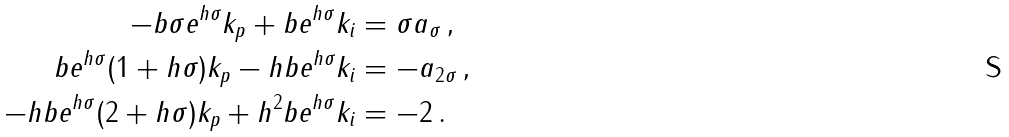Convert formula to latex. <formula><loc_0><loc_0><loc_500><loc_500>- b \sigma e ^ { h \sigma } k _ { p } + b e ^ { h \sigma } k _ { i } & = \sigma a _ { \sigma } \, , \\ b e ^ { h \sigma } ( 1 + h \sigma ) k _ { p } - h b e ^ { h \sigma } k _ { i } & = - a _ { 2 \sigma } \, , \\ - h b e ^ { h \sigma } ( 2 + h \sigma ) k _ { p } + h ^ { 2 } b e ^ { h \sigma } k _ { i } & = - 2 \, .</formula> 